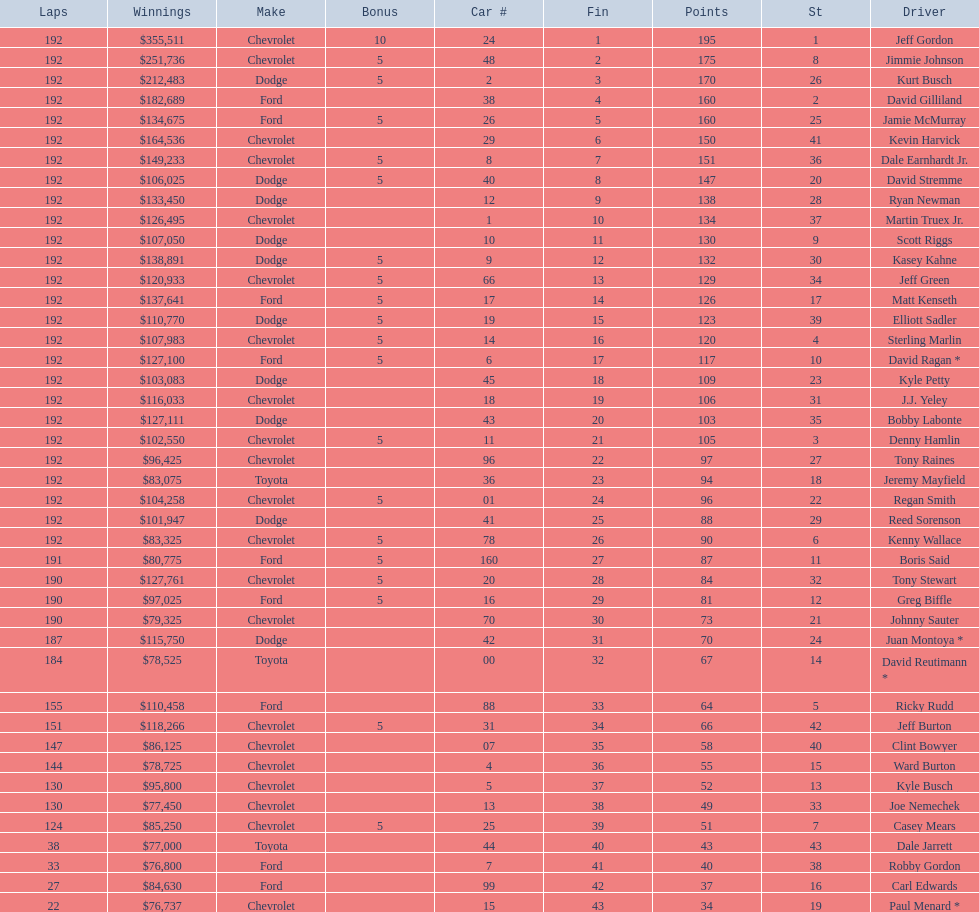What driver earned the least amount of winnings? Paul Menard *. 